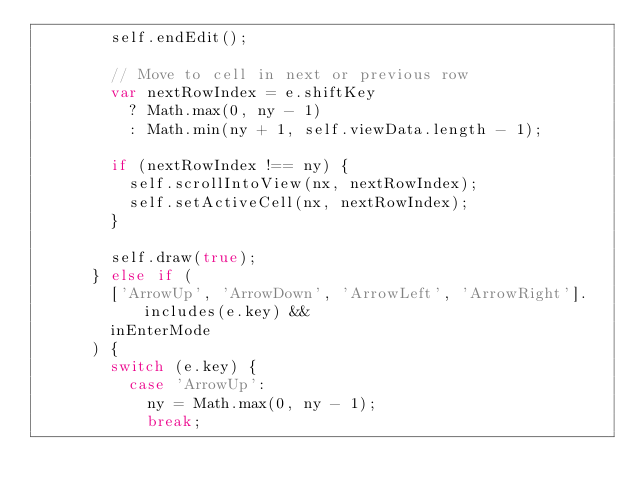<code> <loc_0><loc_0><loc_500><loc_500><_JavaScript_>        self.endEdit();

        // Move to cell in next or previous row
        var nextRowIndex = e.shiftKey
          ? Math.max(0, ny - 1)
          : Math.min(ny + 1, self.viewData.length - 1);

        if (nextRowIndex !== ny) {
          self.scrollIntoView(nx, nextRowIndex);
          self.setActiveCell(nx, nextRowIndex);
        }

        self.draw(true);
      } else if (
        ['ArrowUp', 'ArrowDown', 'ArrowLeft', 'ArrowRight'].includes(e.key) &&
        inEnterMode
      ) {
        switch (e.key) {
          case 'ArrowUp':
            ny = Math.max(0, ny - 1);
            break;</code> 